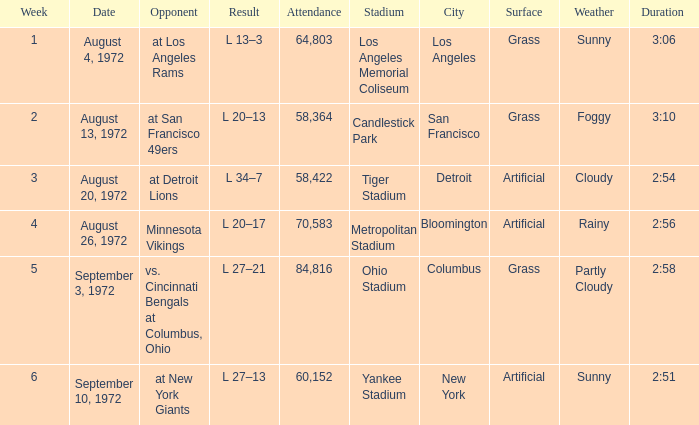What is the lowest attendance on September 3, 1972? 84816.0. 